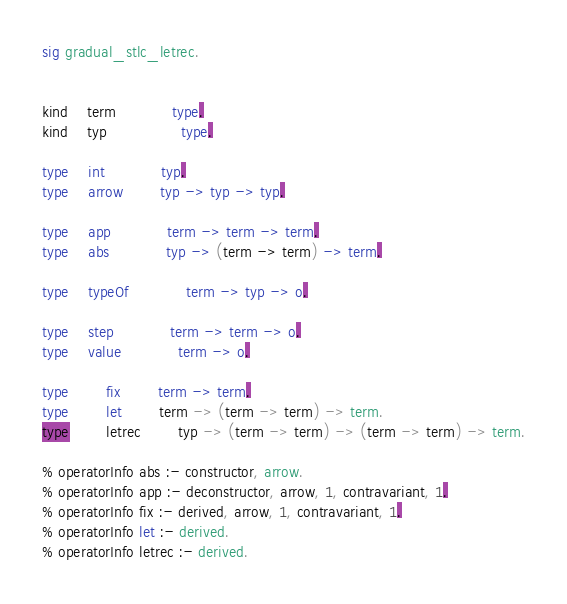Convert code to text. <code><loc_0><loc_0><loc_500><loc_500><_SML_>sig gradual_stlc_letrec.


kind	term			type.
kind	typ				type.

type	int			typ.
type	arrow		typ -> typ -> typ.

type    app			term -> term -> term.
type    abs			typ -> (term -> term) -> term.

type	typeOf			term -> typ -> o. 

type	step			term -> term -> o.
type	value			term -> o.

type		fix		term -> term.
type		let		term -> (term -> term) -> term.
type		letrec		typ -> (term -> term) -> (term -> term) -> term.

% operatorInfo abs :- constructor, arrow.
% operatorInfo app :- deconstructor, arrow, 1, contravariant, 1.
% operatorInfo fix :- derived, arrow, 1, contravariant, 1.
% operatorInfo let :- derived.
% operatorInfo letrec :- derived.</code> 